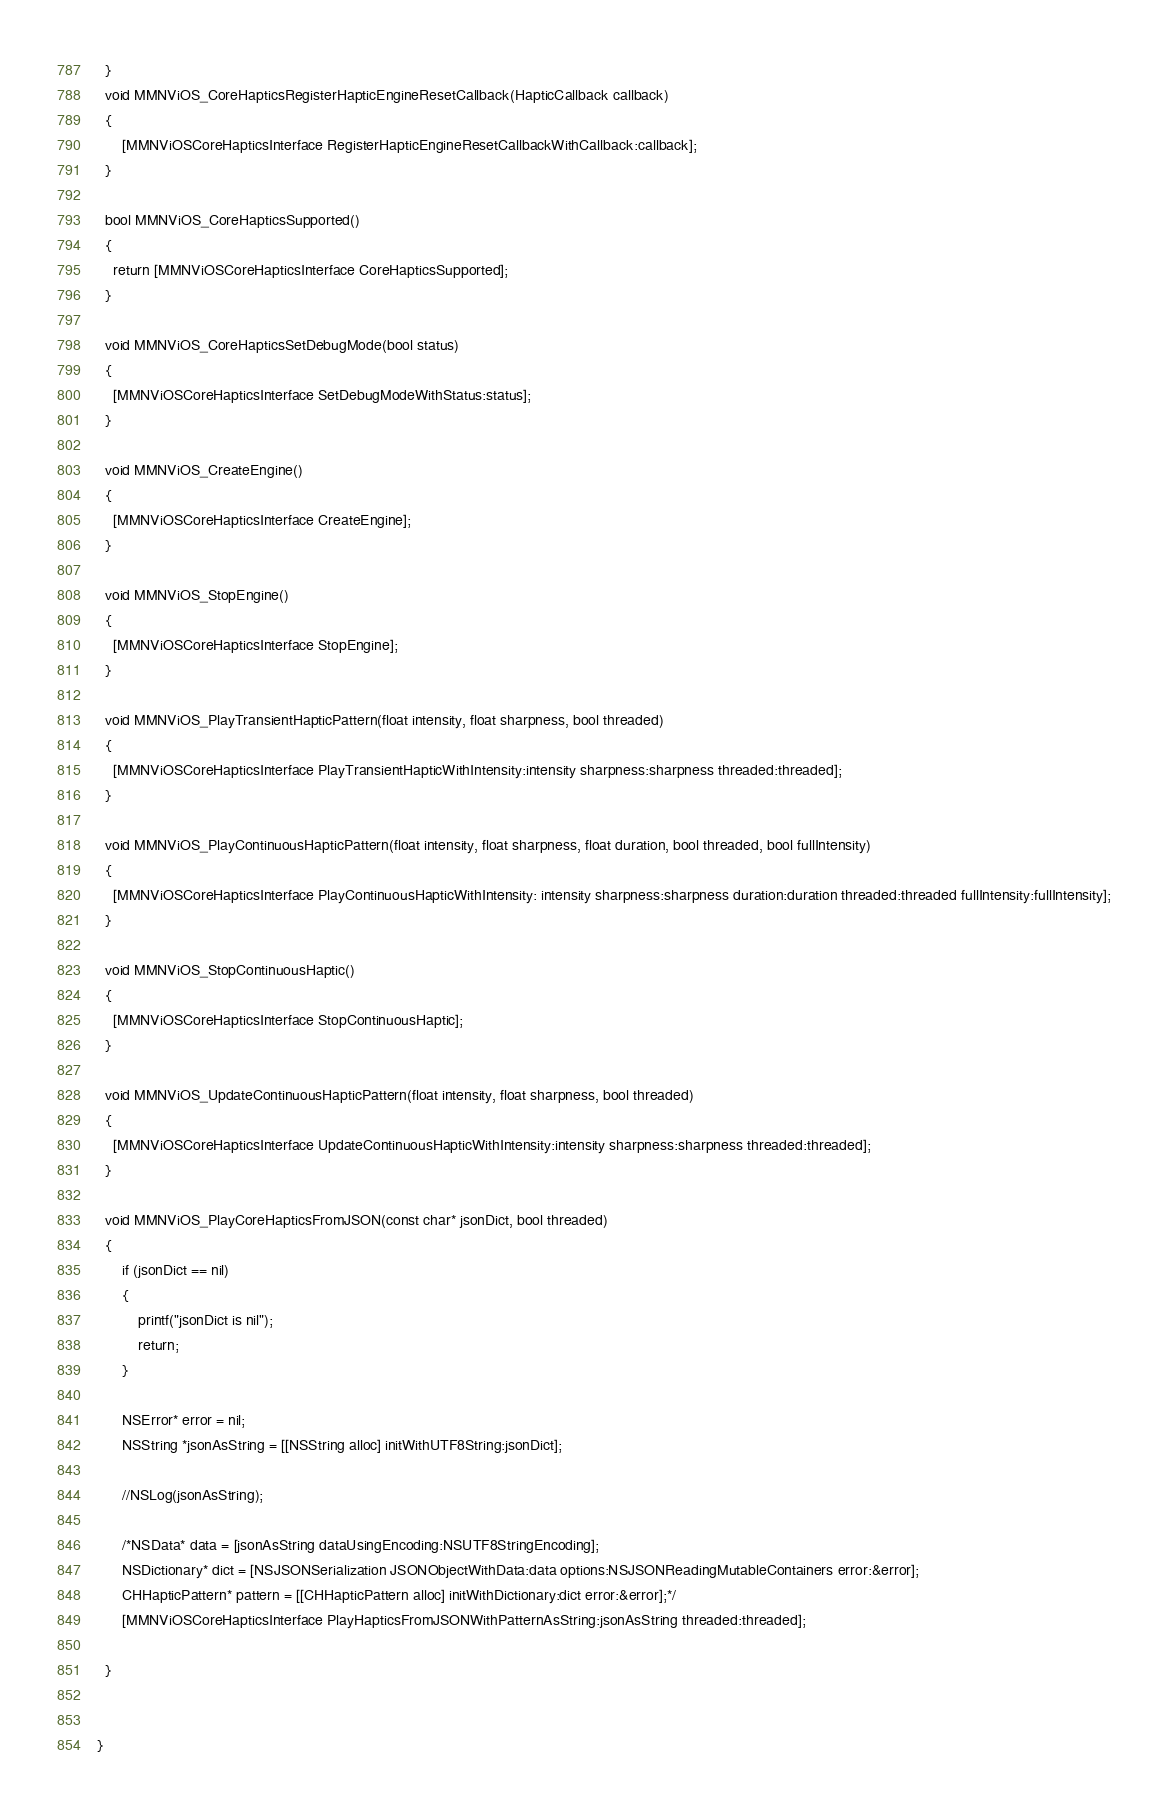<code> <loc_0><loc_0><loc_500><loc_500><_ObjectiveC_>  }
  void MMNViOS_CoreHapticsRegisterHapticEngineResetCallback(HapticCallback callback)
  {
      [MMNViOSCoreHapticsInterface RegisterHapticEngineResetCallbackWithCallback:callback];
  }

  bool MMNViOS_CoreHapticsSupported()
  {
    return [MMNViOSCoreHapticsInterface CoreHapticsSupported];
  }

  void MMNViOS_CoreHapticsSetDebugMode(bool status)
  {
	[MMNViOSCoreHapticsInterface SetDebugModeWithStatus:status];
  }

  void MMNViOS_CreateEngine()
  {
    [MMNViOSCoreHapticsInterface CreateEngine];
  }

  void MMNViOS_StopEngine()
  {
    [MMNViOSCoreHapticsInterface StopEngine];
  }

  void MMNViOS_PlayTransientHapticPattern(float intensity, float sharpness, bool threaded)
  {
    [MMNViOSCoreHapticsInterface PlayTransientHapticWithIntensity:intensity sharpness:sharpness threaded:threaded];
  }

  void MMNViOS_PlayContinuousHapticPattern(float intensity, float sharpness, float duration, bool threaded, bool fullIntensity)
  {
    [MMNViOSCoreHapticsInterface PlayContinuousHapticWithIntensity: intensity sharpness:sharpness duration:duration threaded:threaded fullIntensity:fullIntensity];
  }

  void MMNViOS_StopContinuousHaptic()
  {
    [MMNViOSCoreHapticsInterface StopContinuousHaptic];
  }

  void MMNViOS_UpdateContinuousHapticPattern(float intensity, float sharpness, bool threaded)
  {
    [MMNViOSCoreHapticsInterface UpdateContinuousHapticWithIntensity:intensity sharpness:sharpness threaded:threaded];
  }

  void MMNViOS_PlayCoreHapticsFromJSON(const char* jsonDict, bool threaded)
  {
      if (jsonDict == nil)
      {
          printf("jsonDict is nil");
          return;
      }

      NSError* error = nil;
      NSString *jsonAsString = [[NSString alloc] initWithUTF8String:jsonDict];

      //NSLog(jsonAsString);

      /*NSData* data = [jsonAsString dataUsingEncoding:NSUTF8StringEncoding];
      NSDictionary* dict = [NSJSONSerialization JSONObjectWithData:data options:NSJSONReadingMutableContainers error:&error];
      CHHapticPattern* pattern = [[CHHapticPattern alloc] initWithDictionary:dict error:&error];*/
      [MMNViOSCoreHapticsInterface PlayHapticsFromJSONWithPatternAsString:jsonAsString threaded:threaded];

  }


}
</code> 